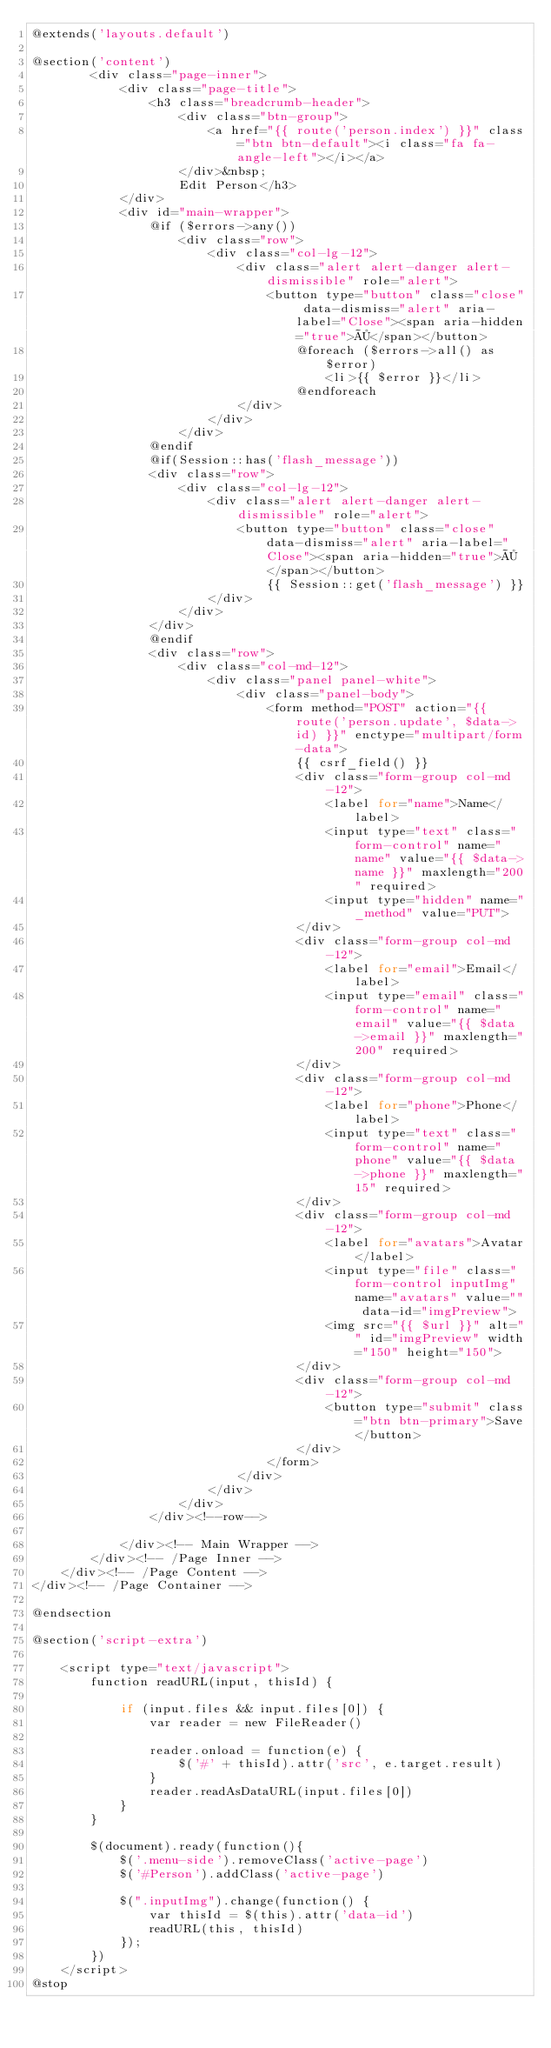<code> <loc_0><loc_0><loc_500><loc_500><_PHP_>@extends('layouts.default')

@section('content')
        <div class="page-inner">
            <div class="page-title">
                <h3 class="breadcrumb-header">
                    <div class="btn-group">
                        <a href="{{ route('person.index') }}" class="btn btn-default"><i class="fa fa-angle-left"></i></a>
                    </div>&nbsp;
                    Edit Person</h3>
            </div>
            <div id="main-wrapper">
                @if ($errors->any())
                    <div class="row">
                        <div class="col-lg-12">
                            <div class="alert alert-danger alert-dismissible" role="alert">
                                <button type="button" class="close" data-dismiss="alert" aria-label="Close"><span aria-hidden="true">×</span></button>
                                    @foreach ($errors->all() as $error)
                                        <li>{{ $error }}</li>
                                    @endforeach
                            </div>
                        </div>
                    </div>
                @endif
                @if(Session::has('flash_message'))
                <div class="row">
                    <div class="col-lg-12">
                        <div class="alert alert-danger alert-dismissible" role="alert">
                            <button type="button" class="close" data-dismiss="alert" aria-label="Close"><span aria-hidden="true">×</span></button>
                                {{ Session::get('flash_message') }}
                        </div>
                    </div>
                </div> 
                @endif
                <div class="row">
                    <div class="col-md-12">
                        <div class="panel panel-white">
                            <div class="panel-body">
                                <form method="POST" action="{{ route('person.update', $data->id) }}" enctype="multipart/form-data">
                                    {{ csrf_field() }}
                                    <div class="form-group col-md-12">
                                        <label for="name">Name</label>
                                        <input type="text" class="form-control" name="name" value="{{ $data->name }}" maxlength="200" required>
                                        <input type="hidden" name="_method" value="PUT">
                                    </div>
                                    <div class="form-group col-md-12">
                                        <label for="email">Email</label>
                                        <input type="email" class="form-control" name="email" value="{{ $data->email }}" maxlength="200" required>
                                    </div>
                                    <div class="form-group col-md-12">
                                        <label for="phone">Phone</label>
                                        <input type="text" class="form-control" name="phone" value="{{ $data->phone }}" maxlength="15" required>
                                    </div>
                                    <div class="form-group col-md-12">
                                        <label for="avatars">Avatar</label>
                                        <input type="file" class="form-control inputImg" name="avatars" value="" data-id="imgPreview">
                                        <img src="{{ $url }}" alt="" id="imgPreview" width="150" height="150">
                                    </div>
                                    <div class="form-group col-md-12">
                                        <button type="submit" class="btn btn-primary">Save</button>
                                    </div>
                                </form>
                            </div>
                        </div>
                    </div>
                </div><!--row-->

            </div><!-- Main Wrapper -->
        </div><!-- /Page Inner -->
    </div><!-- /Page Content -->
</div><!-- /Page Container -->
            
@endsection

@section('script-extra')
    
    <script type="text/javascript">
        function readURL(input, thisId) {

            if (input.files && input.files[0]) {
                var reader = new FileReader()

                reader.onload = function(e) {
                    $('#' + thisId).attr('src', e.target.result)
                }
                reader.readAsDataURL(input.files[0])
            }
        }

        $(document).ready(function(){
            $('.menu-side').removeClass('active-page')
            $('#Person').addClass('active-page')     
            
            $(".inputImg").change(function() {
                var thisId = $(this).attr('data-id')
                readURL(this, thisId)
            });
        })
    </script>
@stop</code> 